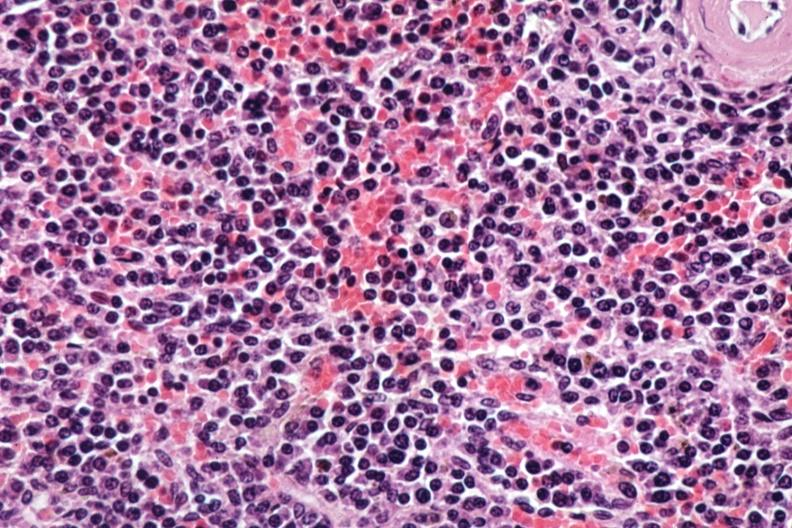what is present?
Answer the question using a single word or phrase. Hematologic 